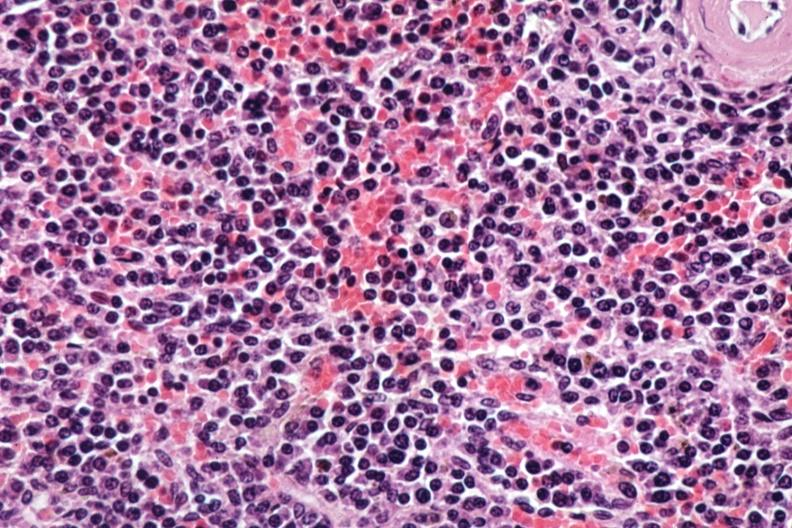what is present?
Answer the question using a single word or phrase. Hematologic 